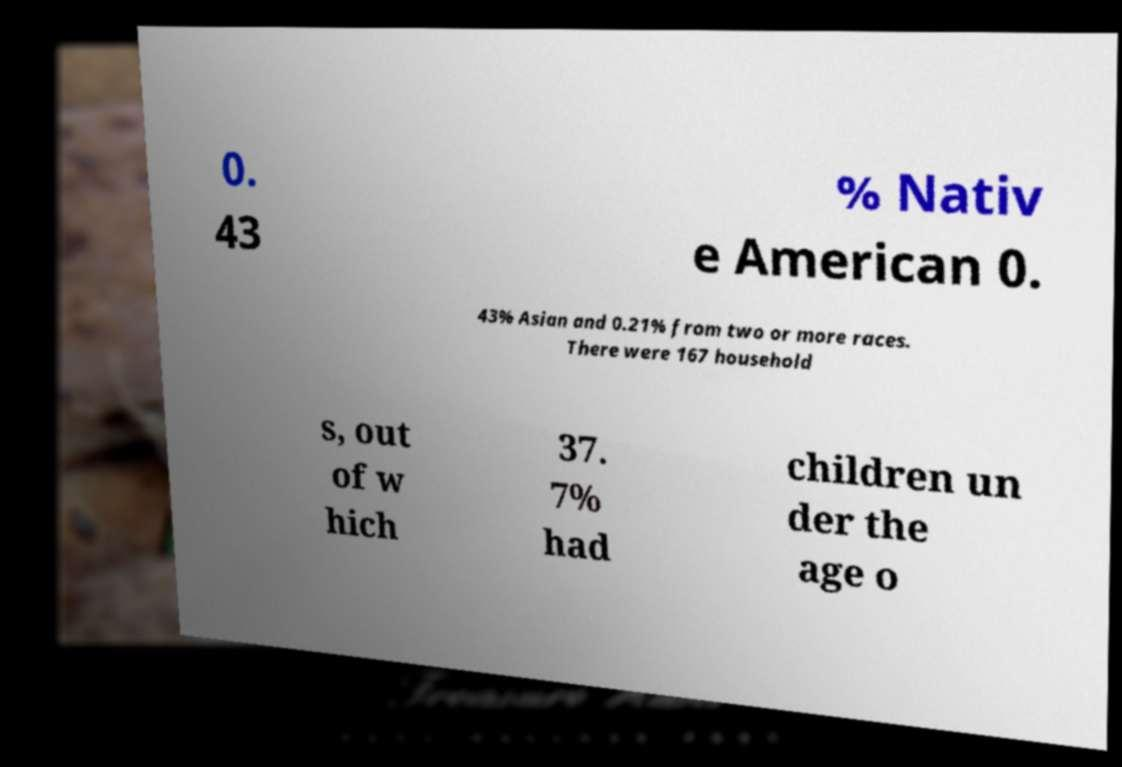For documentation purposes, I need the text within this image transcribed. Could you provide that? 0. 43 % Nativ e American 0. 43% Asian and 0.21% from two or more races. There were 167 household s, out of w hich 37. 7% had children un der the age o 